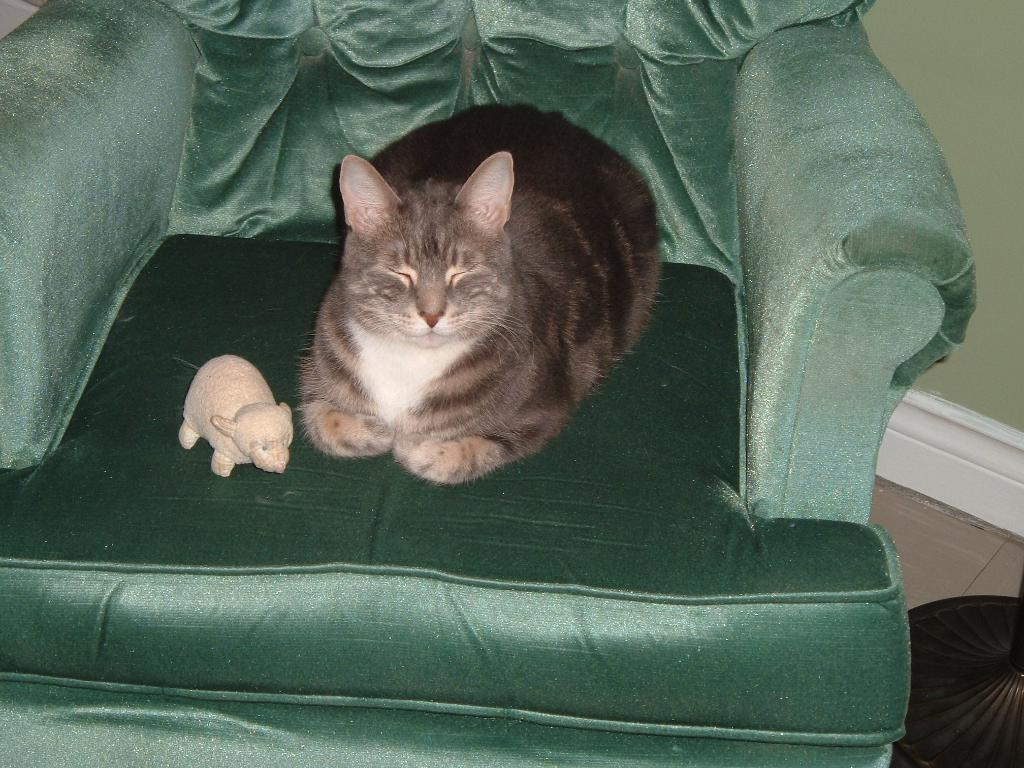What is located in the foreground area on the sofa in the image? There is a cat and a toy in the foreground area on the sofa in the image. Can you describe the cat's position or posture? The facts provided do not give information about the cat's position or posture. What can be seen in the bottom right side of the image? There appears to be a lamp pole in the bottom right side of the image. What type of pain is the cat experiencing in the image? There is no indication in the image that the cat is experiencing any pain. Can you tell me how many times the grandmother appears in the image? There is no mention of a grandmother in the image, so it is not possible to answer that question. 